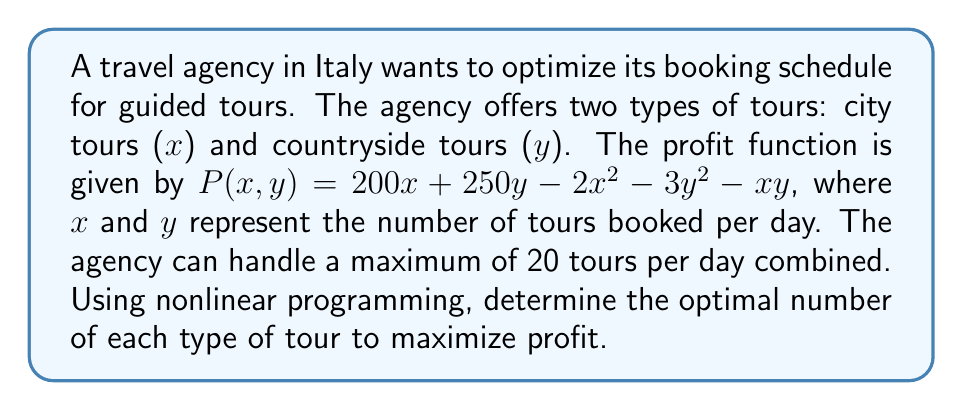Can you answer this question? To solve this optimization problem, we'll use the method of Lagrange multipliers:

1) Define the objective function:
   $P(x,y) = 200x + 250y - 2x^2 - 3y^2 - xy$

2) Define the constraint:
   $g(x,y) = x + y - 20 = 0$

3) Form the Lagrangian:
   $L(x,y,\lambda) = P(x,y) - \lambda g(x,y)$
   $L(x,y,\lambda) = 200x + 250y - 2x^2 - 3y^2 - xy - \lambda(x + y - 20)$

4) Set partial derivatives to zero:
   $\frac{\partial L}{\partial x} = 200 - 4x - y - \lambda = 0$
   $\frac{\partial L}{\partial y} = 250 - 6y - x - \lambda = 0$
   $\frac{\partial L}{\partial \lambda} = x + y - 20 = 0$

5) Solve the system of equations:
   From (1): $\lambda = 200 - 4x - y$
   From (2): $\lambda = 250 - 6y - x$
   Equating these: $200 - 4x - y = 250 - 6y - x$
   Simplifying: $3x = 50 + 5y$
   $x = \frac{50 + 5y}{3}$

   Substitute into constraint equation:
   $\frac{50 + 5y}{3} + y = 20$
   $50 + 5y + 3y = 60$
   $8y = 10$
   $y = 1.25$

   Substitute back:
   $x = \frac{50 + 5(1.25)}{3} = 18.75$

6) Round to nearest whole number:
   $x = 19$ (city tours)
   $y = 1$ (countryside tour)

7) Verify maximum:
   Check second partial derivatives to confirm this is a maximum.

8) Calculate maximum profit:
   $P(19,1) = 200(19) + 250(1) - 2(19)^2 - 3(1)^2 - 19(1) = 2684$
Answer: 19 city tours, 1 countryside tour; Maximum profit: €2684 